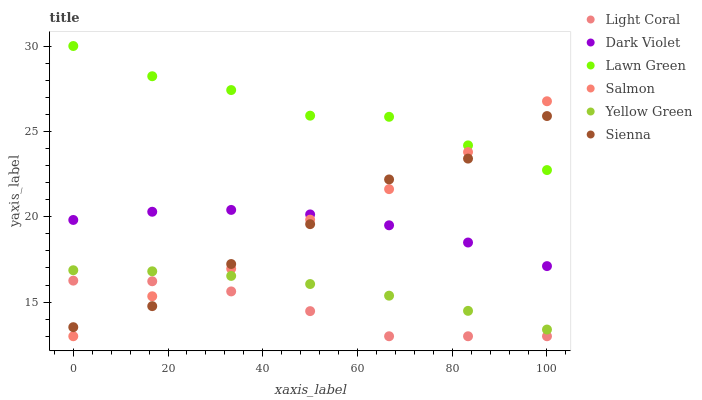Does Light Coral have the minimum area under the curve?
Answer yes or no. Yes. Does Lawn Green have the maximum area under the curve?
Answer yes or no. Yes. Does Yellow Green have the minimum area under the curve?
Answer yes or no. No. Does Yellow Green have the maximum area under the curve?
Answer yes or no. No. Is Yellow Green the smoothest?
Answer yes or no. Yes. Is Lawn Green the roughest?
Answer yes or no. Yes. Is Salmon the smoothest?
Answer yes or no. No. Is Salmon the roughest?
Answer yes or no. No. Does Salmon have the lowest value?
Answer yes or no. Yes. Does Yellow Green have the lowest value?
Answer yes or no. No. Does Lawn Green have the highest value?
Answer yes or no. Yes. Does Yellow Green have the highest value?
Answer yes or no. No. Is Light Coral less than Yellow Green?
Answer yes or no. Yes. Is Lawn Green greater than Dark Violet?
Answer yes or no. Yes. Does Sienna intersect Light Coral?
Answer yes or no. Yes. Is Sienna less than Light Coral?
Answer yes or no. No. Is Sienna greater than Light Coral?
Answer yes or no. No. Does Light Coral intersect Yellow Green?
Answer yes or no. No. 